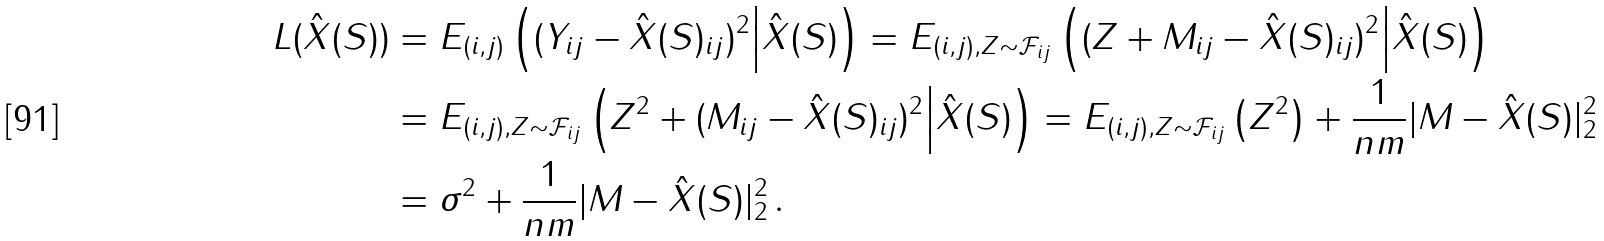Convert formula to latex. <formula><loc_0><loc_0><loc_500><loc_500>L ( \hat { X } ( S ) ) & = E _ { ( i , j ) } \left ( ( Y _ { i j } - \hat { X } ( S ) _ { i j } ) ^ { 2 } \Big | \hat { X } ( S ) \right ) = E _ { ( i , j ) , Z \sim \mathcal { F } _ { i j } } \left ( ( Z + M _ { i j } - \hat { X } ( S ) _ { i j } ) ^ { 2 } \Big | \hat { X } ( S ) \right ) \\ & = E _ { ( i , j ) , Z \sim \mathcal { F } _ { i j } } \left ( Z ^ { 2 } + ( M _ { i j } - \hat { X } ( S ) _ { i j } ) ^ { 2 } \Big | \hat { X } ( S ) \right ) = E _ { ( i , j ) , Z \sim \mathcal { F } _ { i j } } \left ( Z ^ { 2 } \right ) + \frac { 1 } { n m } | M - \hat { X } ( S ) | ^ { 2 } _ { 2 } \\ & = \sigma ^ { 2 } + \frac { 1 } { n m } | M - \hat { X } ( S ) | ^ { 2 } _ { 2 } \, .</formula> 